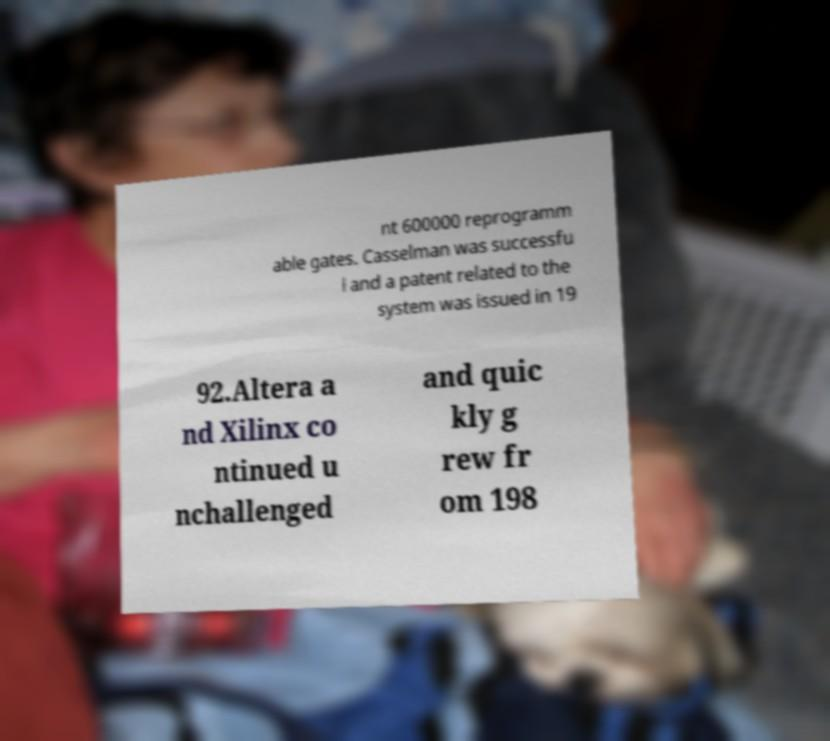Can you accurately transcribe the text from the provided image for me? nt 600000 reprogramm able gates. Casselman was successfu l and a patent related to the system was issued in 19 92.Altera a nd Xilinx co ntinued u nchallenged and quic kly g rew fr om 198 